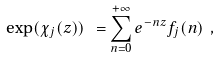<formula> <loc_0><loc_0><loc_500><loc_500>\exp ( \chi _ { j } ( z ) ) \ = \sum _ { n = 0 } ^ { + \infty } e ^ { - n z } f _ { j } ( n ) \ ,</formula> 